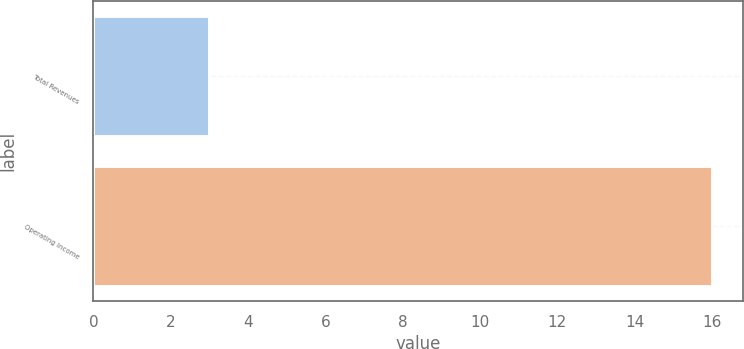Convert chart to OTSL. <chart><loc_0><loc_0><loc_500><loc_500><bar_chart><fcel>Total Revenues<fcel>Operating Income<nl><fcel>3<fcel>16<nl></chart> 